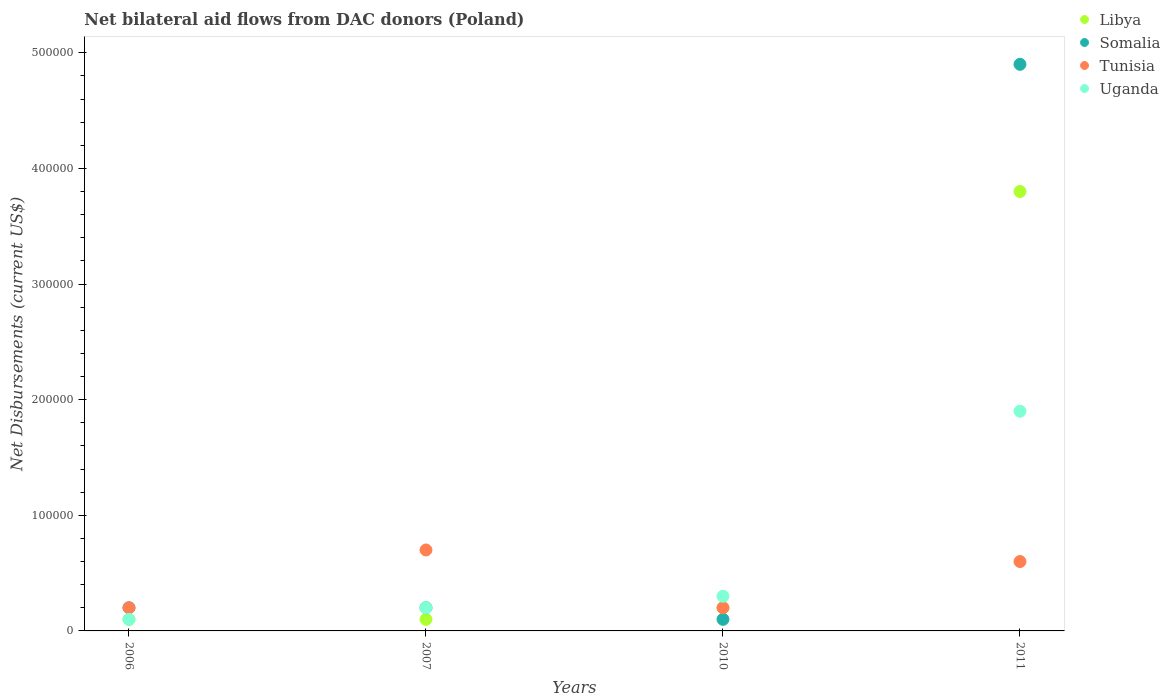Across all years, what is the minimum net bilateral aid flows in Uganda?
Provide a succinct answer. 10000. In which year was the net bilateral aid flows in Somalia minimum?
Ensure brevity in your answer.  2010. What is the total net bilateral aid flows in Somalia in the graph?
Your answer should be compact. 5.40e+05. What is the difference between the net bilateral aid flows in Somalia in 2010 and the net bilateral aid flows in Uganda in 2007?
Your answer should be compact. -10000. What is the average net bilateral aid flows in Somalia per year?
Keep it short and to the point. 1.35e+05. In the year 2010, what is the difference between the net bilateral aid flows in Somalia and net bilateral aid flows in Libya?
Offer a terse response. -10000. What is the ratio of the net bilateral aid flows in Somalia in 2010 to that in 2011?
Ensure brevity in your answer.  0.02. Is the sum of the net bilateral aid flows in Somalia in 2007 and 2011 greater than the maximum net bilateral aid flows in Tunisia across all years?
Your answer should be very brief. Yes. Is it the case that in every year, the sum of the net bilateral aid flows in Tunisia and net bilateral aid flows in Libya  is greater than the sum of net bilateral aid flows in Somalia and net bilateral aid flows in Uganda?
Keep it short and to the point. No. Is the net bilateral aid flows in Libya strictly greater than the net bilateral aid flows in Uganda over the years?
Your answer should be very brief. No. How many dotlines are there?
Offer a very short reply. 4. How many years are there in the graph?
Your answer should be compact. 4. Does the graph contain any zero values?
Your response must be concise. No. Where does the legend appear in the graph?
Give a very brief answer. Top right. What is the title of the graph?
Provide a succinct answer. Net bilateral aid flows from DAC donors (Poland). What is the label or title of the X-axis?
Provide a succinct answer. Years. What is the label or title of the Y-axis?
Keep it short and to the point. Net Disbursements (current US$). What is the Net Disbursements (current US$) of Somalia in 2006?
Your response must be concise. 2.00e+04. What is the Net Disbursements (current US$) of Tunisia in 2006?
Give a very brief answer. 2.00e+04. What is the Net Disbursements (current US$) of Libya in 2007?
Give a very brief answer. 10000. What is the Net Disbursements (current US$) of Somalia in 2007?
Ensure brevity in your answer.  2.00e+04. What is the Net Disbursements (current US$) in Tunisia in 2007?
Your answer should be compact. 7.00e+04. What is the Net Disbursements (current US$) of Uganda in 2007?
Make the answer very short. 2.00e+04. What is the Net Disbursements (current US$) of Libya in 2010?
Give a very brief answer. 2.00e+04. What is the Net Disbursements (current US$) of Somalia in 2010?
Offer a very short reply. 10000. What is the Net Disbursements (current US$) of Tunisia in 2010?
Your answer should be very brief. 2.00e+04. What is the Net Disbursements (current US$) in Uganda in 2010?
Offer a very short reply. 3.00e+04. What is the Net Disbursements (current US$) of Libya in 2011?
Offer a terse response. 3.80e+05. What is the Net Disbursements (current US$) of Somalia in 2011?
Offer a terse response. 4.90e+05. Across all years, what is the maximum Net Disbursements (current US$) of Somalia?
Provide a short and direct response. 4.90e+05. Across all years, what is the maximum Net Disbursements (current US$) in Tunisia?
Your answer should be very brief. 7.00e+04. Across all years, what is the maximum Net Disbursements (current US$) in Uganda?
Provide a succinct answer. 1.90e+05. Across all years, what is the minimum Net Disbursements (current US$) of Libya?
Make the answer very short. 10000. Across all years, what is the minimum Net Disbursements (current US$) of Tunisia?
Make the answer very short. 2.00e+04. What is the total Net Disbursements (current US$) in Somalia in the graph?
Ensure brevity in your answer.  5.40e+05. What is the difference between the Net Disbursements (current US$) of Libya in 2006 and that in 2007?
Provide a short and direct response. 0. What is the difference between the Net Disbursements (current US$) in Somalia in 2006 and that in 2007?
Ensure brevity in your answer.  0. What is the difference between the Net Disbursements (current US$) in Tunisia in 2006 and that in 2007?
Offer a terse response. -5.00e+04. What is the difference between the Net Disbursements (current US$) of Libya in 2006 and that in 2010?
Provide a succinct answer. -10000. What is the difference between the Net Disbursements (current US$) of Libya in 2006 and that in 2011?
Ensure brevity in your answer.  -3.70e+05. What is the difference between the Net Disbursements (current US$) of Somalia in 2006 and that in 2011?
Provide a short and direct response. -4.70e+05. What is the difference between the Net Disbursements (current US$) of Tunisia in 2006 and that in 2011?
Offer a terse response. -4.00e+04. What is the difference between the Net Disbursements (current US$) in Uganda in 2006 and that in 2011?
Make the answer very short. -1.80e+05. What is the difference between the Net Disbursements (current US$) in Libya in 2007 and that in 2010?
Your response must be concise. -10000. What is the difference between the Net Disbursements (current US$) of Uganda in 2007 and that in 2010?
Make the answer very short. -10000. What is the difference between the Net Disbursements (current US$) in Libya in 2007 and that in 2011?
Provide a short and direct response. -3.70e+05. What is the difference between the Net Disbursements (current US$) of Somalia in 2007 and that in 2011?
Offer a very short reply. -4.70e+05. What is the difference between the Net Disbursements (current US$) in Libya in 2010 and that in 2011?
Keep it short and to the point. -3.60e+05. What is the difference between the Net Disbursements (current US$) of Somalia in 2010 and that in 2011?
Your answer should be very brief. -4.80e+05. What is the difference between the Net Disbursements (current US$) in Uganda in 2010 and that in 2011?
Provide a succinct answer. -1.60e+05. What is the difference between the Net Disbursements (current US$) in Libya in 2006 and the Net Disbursements (current US$) in Tunisia in 2007?
Your answer should be very brief. -6.00e+04. What is the difference between the Net Disbursements (current US$) of Libya in 2006 and the Net Disbursements (current US$) of Uganda in 2007?
Your response must be concise. -10000. What is the difference between the Net Disbursements (current US$) of Tunisia in 2006 and the Net Disbursements (current US$) of Uganda in 2007?
Give a very brief answer. 0. What is the difference between the Net Disbursements (current US$) in Libya in 2006 and the Net Disbursements (current US$) in Tunisia in 2010?
Your response must be concise. -10000. What is the difference between the Net Disbursements (current US$) of Libya in 2006 and the Net Disbursements (current US$) of Uganda in 2010?
Make the answer very short. -2.00e+04. What is the difference between the Net Disbursements (current US$) of Somalia in 2006 and the Net Disbursements (current US$) of Tunisia in 2010?
Provide a short and direct response. 0. What is the difference between the Net Disbursements (current US$) in Somalia in 2006 and the Net Disbursements (current US$) in Uganda in 2010?
Give a very brief answer. -10000. What is the difference between the Net Disbursements (current US$) in Libya in 2006 and the Net Disbursements (current US$) in Somalia in 2011?
Your answer should be compact. -4.80e+05. What is the difference between the Net Disbursements (current US$) in Libya in 2006 and the Net Disbursements (current US$) in Tunisia in 2011?
Offer a terse response. -5.00e+04. What is the difference between the Net Disbursements (current US$) in Libya in 2006 and the Net Disbursements (current US$) in Uganda in 2011?
Offer a terse response. -1.80e+05. What is the difference between the Net Disbursements (current US$) of Somalia in 2006 and the Net Disbursements (current US$) of Tunisia in 2011?
Your answer should be compact. -4.00e+04. What is the difference between the Net Disbursements (current US$) in Tunisia in 2006 and the Net Disbursements (current US$) in Uganda in 2011?
Keep it short and to the point. -1.70e+05. What is the difference between the Net Disbursements (current US$) of Libya in 2007 and the Net Disbursements (current US$) of Tunisia in 2010?
Make the answer very short. -10000. What is the difference between the Net Disbursements (current US$) of Somalia in 2007 and the Net Disbursements (current US$) of Tunisia in 2010?
Offer a terse response. 0. What is the difference between the Net Disbursements (current US$) in Libya in 2007 and the Net Disbursements (current US$) in Somalia in 2011?
Offer a very short reply. -4.80e+05. What is the difference between the Net Disbursements (current US$) in Libya in 2007 and the Net Disbursements (current US$) in Tunisia in 2011?
Offer a terse response. -5.00e+04. What is the difference between the Net Disbursements (current US$) of Libya in 2007 and the Net Disbursements (current US$) of Uganda in 2011?
Your answer should be compact. -1.80e+05. What is the difference between the Net Disbursements (current US$) in Tunisia in 2007 and the Net Disbursements (current US$) in Uganda in 2011?
Provide a short and direct response. -1.20e+05. What is the difference between the Net Disbursements (current US$) in Libya in 2010 and the Net Disbursements (current US$) in Somalia in 2011?
Offer a very short reply. -4.70e+05. What is the difference between the Net Disbursements (current US$) in Libya in 2010 and the Net Disbursements (current US$) in Tunisia in 2011?
Provide a succinct answer. -4.00e+04. What is the difference between the Net Disbursements (current US$) of Libya in 2010 and the Net Disbursements (current US$) of Uganda in 2011?
Give a very brief answer. -1.70e+05. What is the average Net Disbursements (current US$) of Libya per year?
Your answer should be compact. 1.05e+05. What is the average Net Disbursements (current US$) in Somalia per year?
Provide a short and direct response. 1.35e+05. What is the average Net Disbursements (current US$) in Tunisia per year?
Provide a short and direct response. 4.25e+04. What is the average Net Disbursements (current US$) in Uganda per year?
Your answer should be compact. 6.25e+04. In the year 2006, what is the difference between the Net Disbursements (current US$) of Libya and Net Disbursements (current US$) of Somalia?
Keep it short and to the point. -10000. In the year 2006, what is the difference between the Net Disbursements (current US$) in Libya and Net Disbursements (current US$) in Tunisia?
Give a very brief answer. -10000. In the year 2006, what is the difference between the Net Disbursements (current US$) of Libya and Net Disbursements (current US$) of Uganda?
Your answer should be very brief. 0. In the year 2006, what is the difference between the Net Disbursements (current US$) in Somalia and Net Disbursements (current US$) in Tunisia?
Make the answer very short. 0. In the year 2007, what is the difference between the Net Disbursements (current US$) of Libya and Net Disbursements (current US$) of Somalia?
Offer a very short reply. -10000. In the year 2007, what is the difference between the Net Disbursements (current US$) of Libya and Net Disbursements (current US$) of Tunisia?
Give a very brief answer. -6.00e+04. In the year 2007, what is the difference between the Net Disbursements (current US$) of Somalia and Net Disbursements (current US$) of Tunisia?
Keep it short and to the point. -5.00e+04. In the year 2007, what is the difference between the Net Disbursements (current US$) in Somalia and Net Disbursements (current US$) in Uganda?
Your response must be concise. 0. In the year 2010, what is the difference between the Net Disbursements (current US$) in Libya and Net Disbursements (current US$) in Somalia?
Your answer should be very brief. 10000. In the year 2010, what is the difference between the Net Disbursements (current US$) in Somalia and Net Disbursements (current US$) in Tunisia?
Offer a terse response. -10000. In the year 2011, what is the difference between the Net Disbursements (current US$) of Libya and Net Disbursements (current US$) of Tunisia?
Your response must be concise. 3.20e+05. In the year 2011, what is the difference between the Net Disbursements (current US$) of Somalia and Net Disbursements (current US$) of Tunisia?
Keep it short and to the point. 4.30e+05. In the year 2011, what is the difference between the Net Disbursements (current US$) of Somalia and Net Disbursements (current US$) of Uganda?
Offer a terse response. 3.00e+05. In the year 2011, what is the difference between the Net Disbursements (current US$) in Tunisia and Net Disbursements (current US$) in Uganda?
Make the answer very short. -1.30e+05. What is the ratio of the Net Disbursements (current US$) of Tunisia in 2006 to that in 2007?
Your answer should be very brief. 0.29. What is the ratio of the Net Disbursements (current US$) in Uganda in 2006 to that in 2007?
Provide a short and direct response. 0.5. What is the ratio of the Net Disbursements (current US$) in Libya in 2006 to that in 2010?
Make the answer very short. 0.5. What is the ratio of the Net Disbursements (current US$) of Somalia in 2006 to that in 2010?
Give a very brief answer. 2. What is the ratio of the Net Disbursements (current US$) in Uganda in 2006 to that in 2010?
Your response must be concise. 0.33. What is the ratio of the Net Disbursements (current US$) in Libya in 2006 to that in 2011?
Provide a short and direct response. 0.03. What is the ratio of the Net Disbursements (current US$) of Somalia in 2006 to that in 2011?
Offer a very short reply. 0.04. What is the ratio of the Net Disbursements (current US$) in Uganda in 2006 to that in 2011?
Your response must be concise. 0.05. What is the ratio of the Net Disbursements (current US$) in Uganda in 2007 to that in 2010?
Your answer should be compact. 0.67. What is the ratio of the Net Disbursements (current US$) in Libya in 2007 to that in 2011?
Provide a short and direct response. 0.03. What is the ratio of the Net Disbursements (current US$) in Somalia in 2007 to that in 2011?
Keep it short and to the point. 0.04. What is the ratio of the Net Disbursements (current US$) of Tunisia in 2007 to that in 2011?
Provide a short and direct response. 1.17. What is the ratio of the Net Disbursements (current US$) in Uganda in 2007 to that in 2011?
Ensure brevity in your answer.  0.11. What is the ratio of the Net Disbursements (current US$) of Libya in 2010 to that in 2011?
Offer a very short reply. 0.05. What is the ratio of the Net Disbursements (current US$) in Somalia in 2010 to that in 2011?
Give a very brief answer. 0.02. What is the ratio of the Net Disbursements (current US$) in Tunisia in 2010 to that in 2011?
Provide a short and direct response. 0.33. What is the ratio of the Net Disbursements (current US$) of Uganda in 2010 to that in 2011?
Your answer should be compact. 0.16. What is the difference between the highest and the second highest Net Disbursements (current US$) of Somalia?
Provide a short and direct response. 4.70e+05. What is the difference between the highest and the second highest Net Disbursements (current US$) in Uganda?
Make the answer very short. 1.60e+05. What is the difference between the highest and the lowest Net Disbursements (current US$) in Libya?
Make the answer very short. 3.70e+05. What is the difference between the highest and the lowest Net Disbursements (current US$) in Somalia?
Offer a terse response. 4.80e+05. 